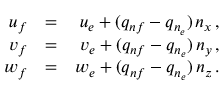Convert formula to latex. <formula><loc_0><loc_0><loc_500><loc_500>\begin{array} { r l r } { { u _ { f } } } & { = } & { { u _ { e } + ( q _ { n f } - q _ { n _ { e } } ) \, n _ { x } \, , } } \\ { { v _ { f } } } & { = } & { { v _ { e } + ( q _ { n f } - q _ { n _ { e } } ) \, n _ { y } \, , } } \\ { { w _ { f } } } & { = } & { { w _ { e } + ( q _ { n f } - q _ { n _ { e } } ) \, n _ { z } \, . } } \end{array}</formula> 